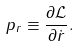Convert formula to latex. <formula><loc_0><loc_0><loc_500><loc_500>p _ { r } \equiv \frac { \partial \mathcal { L } } { \partial \dot { r } } .</formula> 